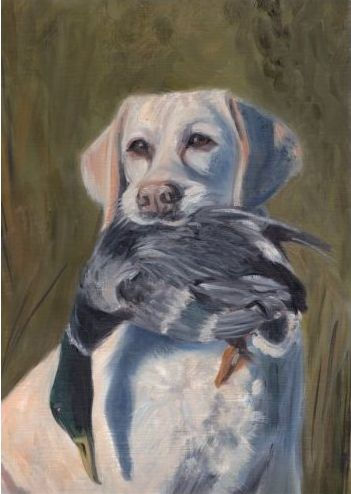<image>Is the dog wearing a collar? I am not sure if the dog is wearing a collar. But it can be seen no. Is the dog wearing a collar? The dog is not wearing a collar. 